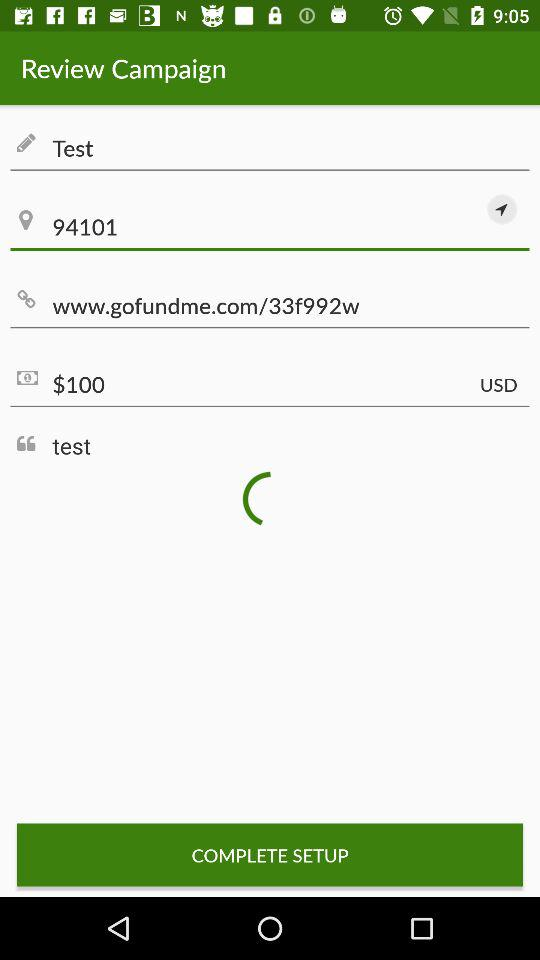What is the pincode for the location given? The pincode for the location given is 94101. 